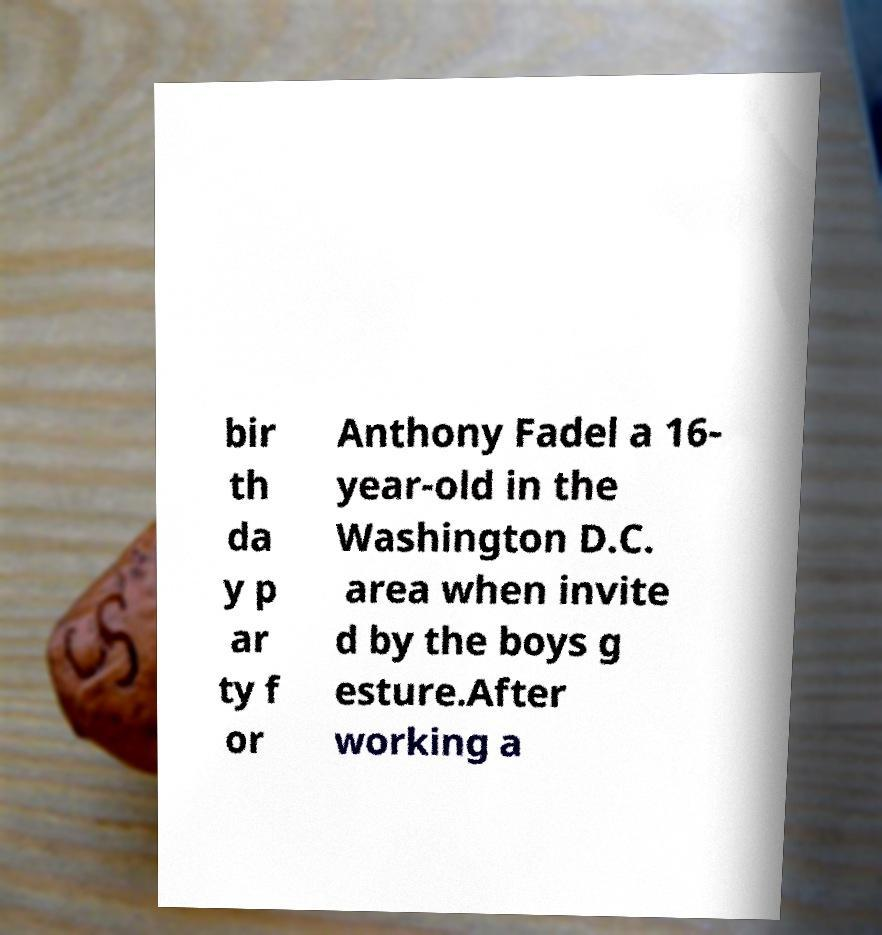I need the written content from this picture converted into text. Can you do that? bir th da y p ar ty f or Anthony Fadel a 16- year-old in the Washington D.C. area when invite d by the boys g esture.After working a 